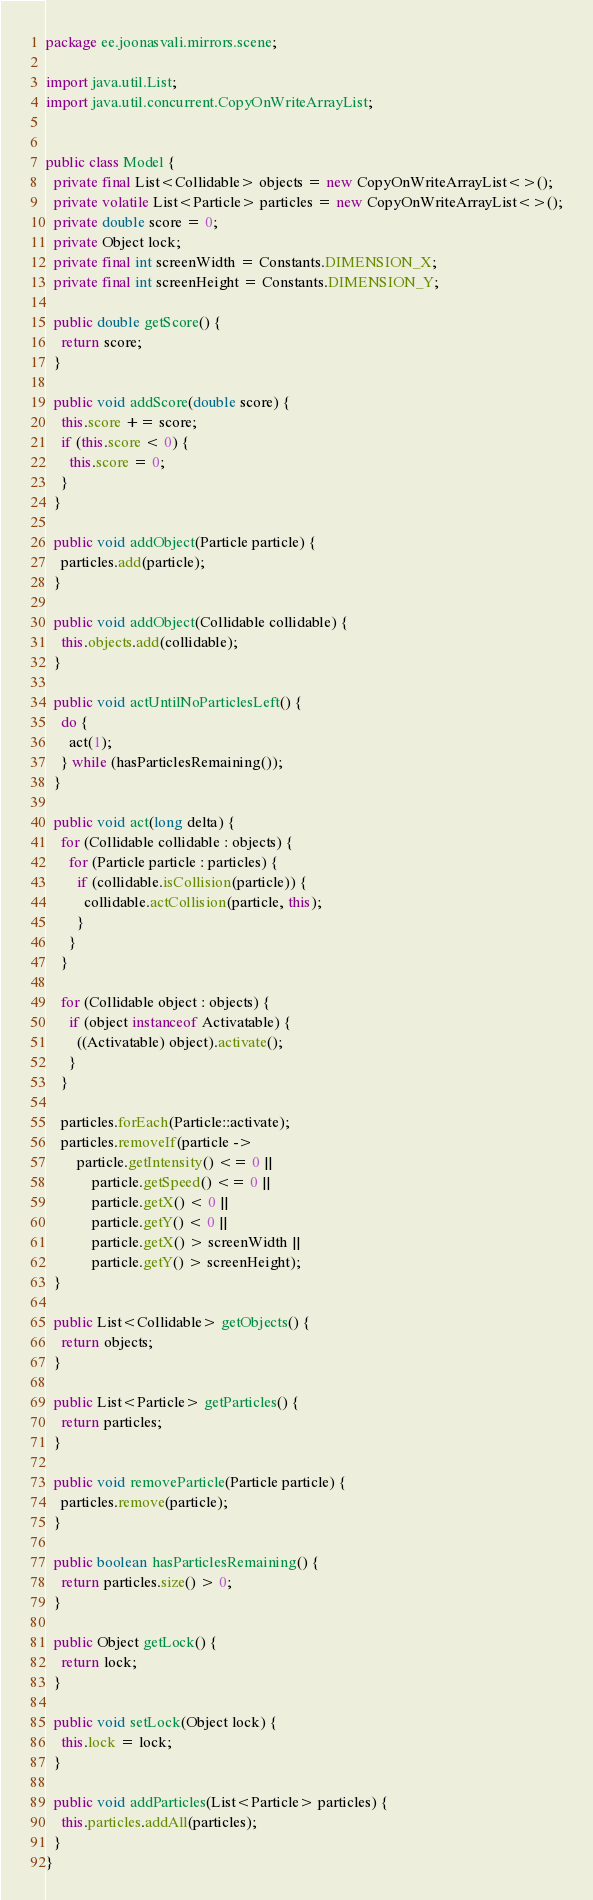Convert code to text. <code><loc_0><loc_0><loc_500><loc_500><_Java_>package ee.joonasvali.mirrors.scene;

import java.util.List;
import java.util.concurrent.CopyOnWriteArrayList;


public class Model {
  private final List<Collidable> objects = new CopyOnWriteArrayList<>();
  private volatile List<Particle> particles = new CopyOnWriteArrayList<>();
  private double score = 0;
  private Object lock;
  private final int screenWidth = Constants.DIMENSION_X;
  private final int screenHeight = Constants.DIMENSION_Y;

  public double getScore() {
    return score;
  }

  public void addScore(double score) {
    this.score += score;
    if (this.score < 0) {
      this.score = 0;
    }
  }

  public void addObject(Particle particle) {
    particles.add(particle);
  }

  public void addObject(Collidable collidable) {
    this.objects.add(collidable);
  }

  public void actUntilNoParticlesLeft() {
    do {
      act(1);
    } while (hasParticlesRemaining());
  }

  public void act(long delta) {
    for (Collidable collidable : objects) {
      for (Particle particle : particles) {
        if (collidable.isCollision(particle)) {
          collidable.actCollision(particle, this);
        }
      }
    }

    for (Collidable object : objects) {
      if (object instanceof Activatable) {
        ((Activatable) object).activate();
      }
    }

    particles.forEach(Particle::activate);
    particles.removeIf(particle ->
        particle.getIntensity() <= 0 ||
            particle.getSpeed() <= 0 ||
            particle.getX() < 0 ||
            particle.getY() < 0 ||
            particle.getX() > screenWidth ||
            particle.getY() > screenHeight);
  }

  public List<Collidable> getObjects() {
    return objects;
  }

  public List<Particle> getParticles() {
    return particles;
  }

  public void removeParticle(Particle particle) {
    particles.remove(particle);
  }

  public boolean hasParticlesRemaining() {
    return particles.size() > 0;
  }

  public Object getLock() {
    return lock;
  }

  public void setLock(Object lock) {
    this.lock = lock;
  }

  public void addParticles(List<Particle> particles) {
    this.particles.addAll(particles);
  }
}
</code> 